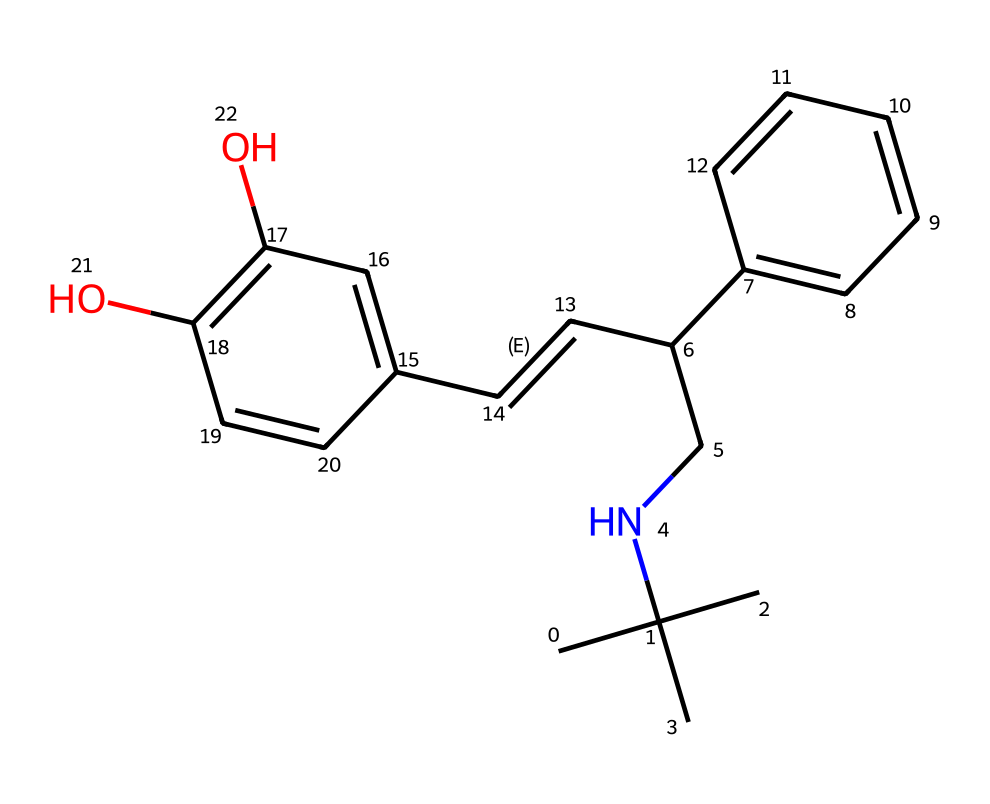What is the molecular formula of this chemical? To determine the molecular formula, we count the number of each type of atom in the provided SMILES. In this case, there are 16 carbons (C), 21 hydrogens (H), and 3 oxygens (O). Therefore, the molecular formula is C16H21O3.
Answer: C16H21O3 How many rings are present in the structure? By examining the SMILES representation, we notice that the structure contains two cyclic components, indicating two rings. This is determined by looking for numbers that denote bond connections that form loops.
Answer: 2 What type of drug is this? This compound is categorized as a bronchodilator, as it is designed to alleviate respiratory issues by relaxing airway muscles. This classification is based on its function in treating conditions like asthma in the chemical's application context.
Answer: bronchodilator How many functional groups can you identify? In the structure, we can identify two hydroxyl (-OH) groups and one amine (-NH) group. In total, there are three functional groups present. This is determined by identifying specific arrangements of atoms that define functional groups.
Answer: 3 What is the main therapeutic effect of this drug? The primary effect of the drug is to open up airways, which alleviates symptoms of respiratory disorders. This conclusion comes from understanding the role of bronchodilators in medical treatment.
Answer: opens airways What specific health condition does this drug primarily treat? This chemical is primarily used to treat asthma. This is recognized by its classification as a bronchodilator and common therapeutic usage in asthma management.
Answer: asthma 